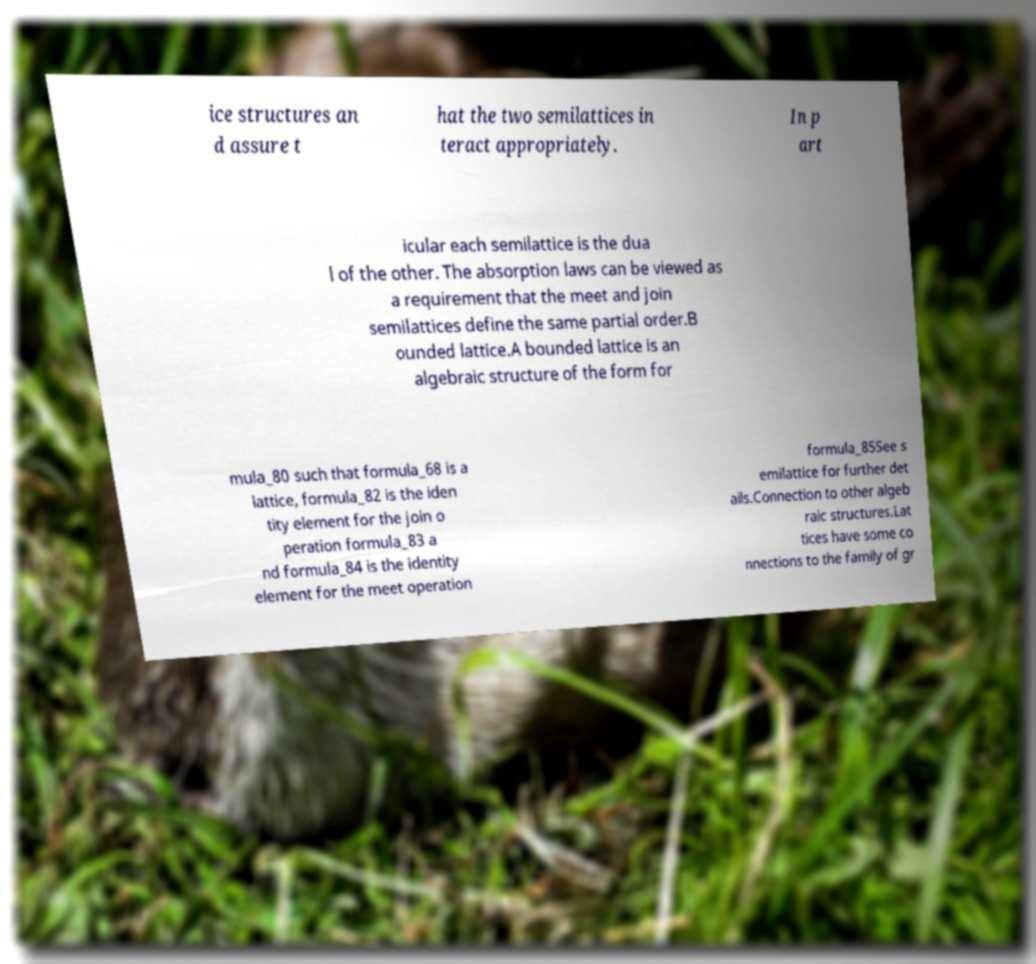Could you assist in decoding the text presented in this image and type it out clearly? ice structures an d assure t hat the two semilattices in teract appropriately. In p art icular each semilattice is the dua l of the other. The absorption laws can be viewed as a requirement that the meet and join semilattices define the same partial order.B ounded lattice.A bounded lattice is an algebraic structure of the form for mula_80 such that formula_68 is a lattice, formula_82 is the iden tity element for the join o peration formula_83 a nd formula_84 is the identity element for the meet operation formula_85See s emilattice for further det ails.Connection to other algeb raic structures.Lat tices have some co nnections to the family of gr 